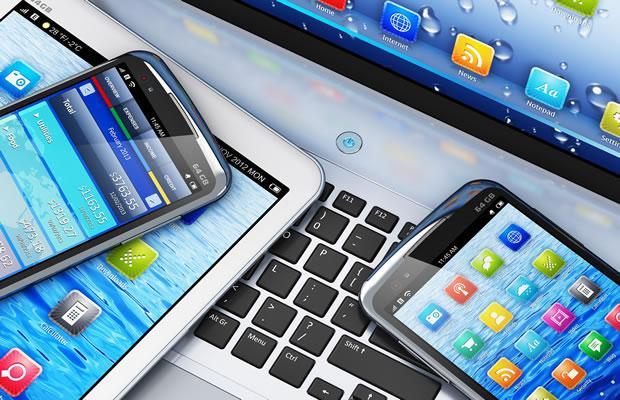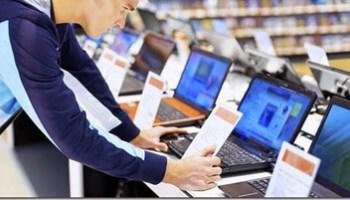The first image is the image on the left, the second image is the image on the right. Assess this claim about the two images: "One image includes at least one laptop with its open screen showing a blue nature-themed picture, and the other image contains one computer keyboard.". Correct or not? Answer yes or no. No. The first image is the image on the left, the second image is the image on the right. Given the left and right images, does the statement "There are more than two laptops." hold true? Answer yes or no. Yes. 